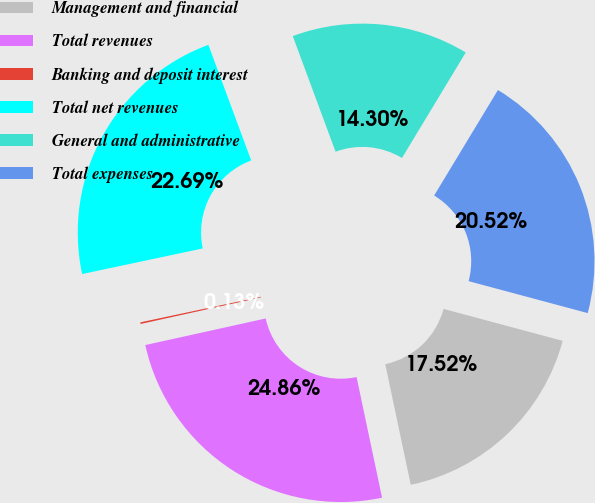Convert chart. <chart><loc_0><loc_0><loc_500><loc_500><pie_chart><fcel>Management and financial<fcel>Total revenues<fcel>Banking and deposit interest<fcel>Total net revenues<fcel>General and administrative<fcel>Total expenses<nl><fcel>17.52%<fcel>24.86%<fcel>0.13%<fcel>22.69%<fcel>14.3%<fcel>20.52%<nl></chart> 